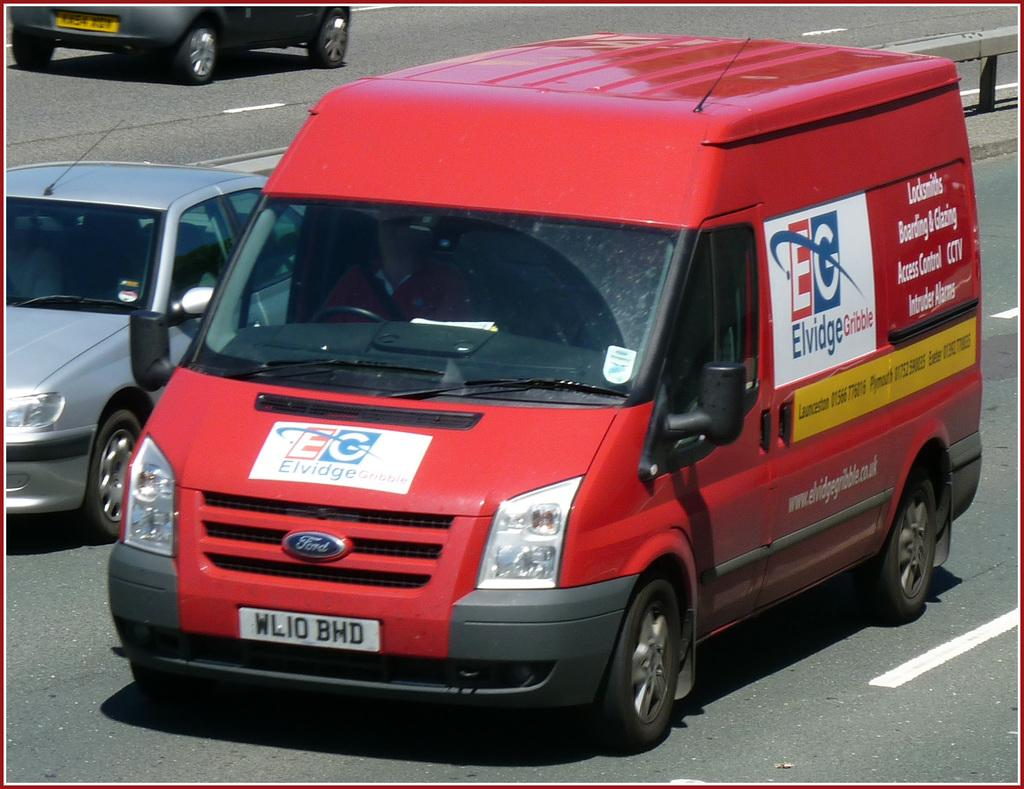<image>
Describe the image concisely. A red Eldridge Gribble van with the license plate WLIO BHD. 